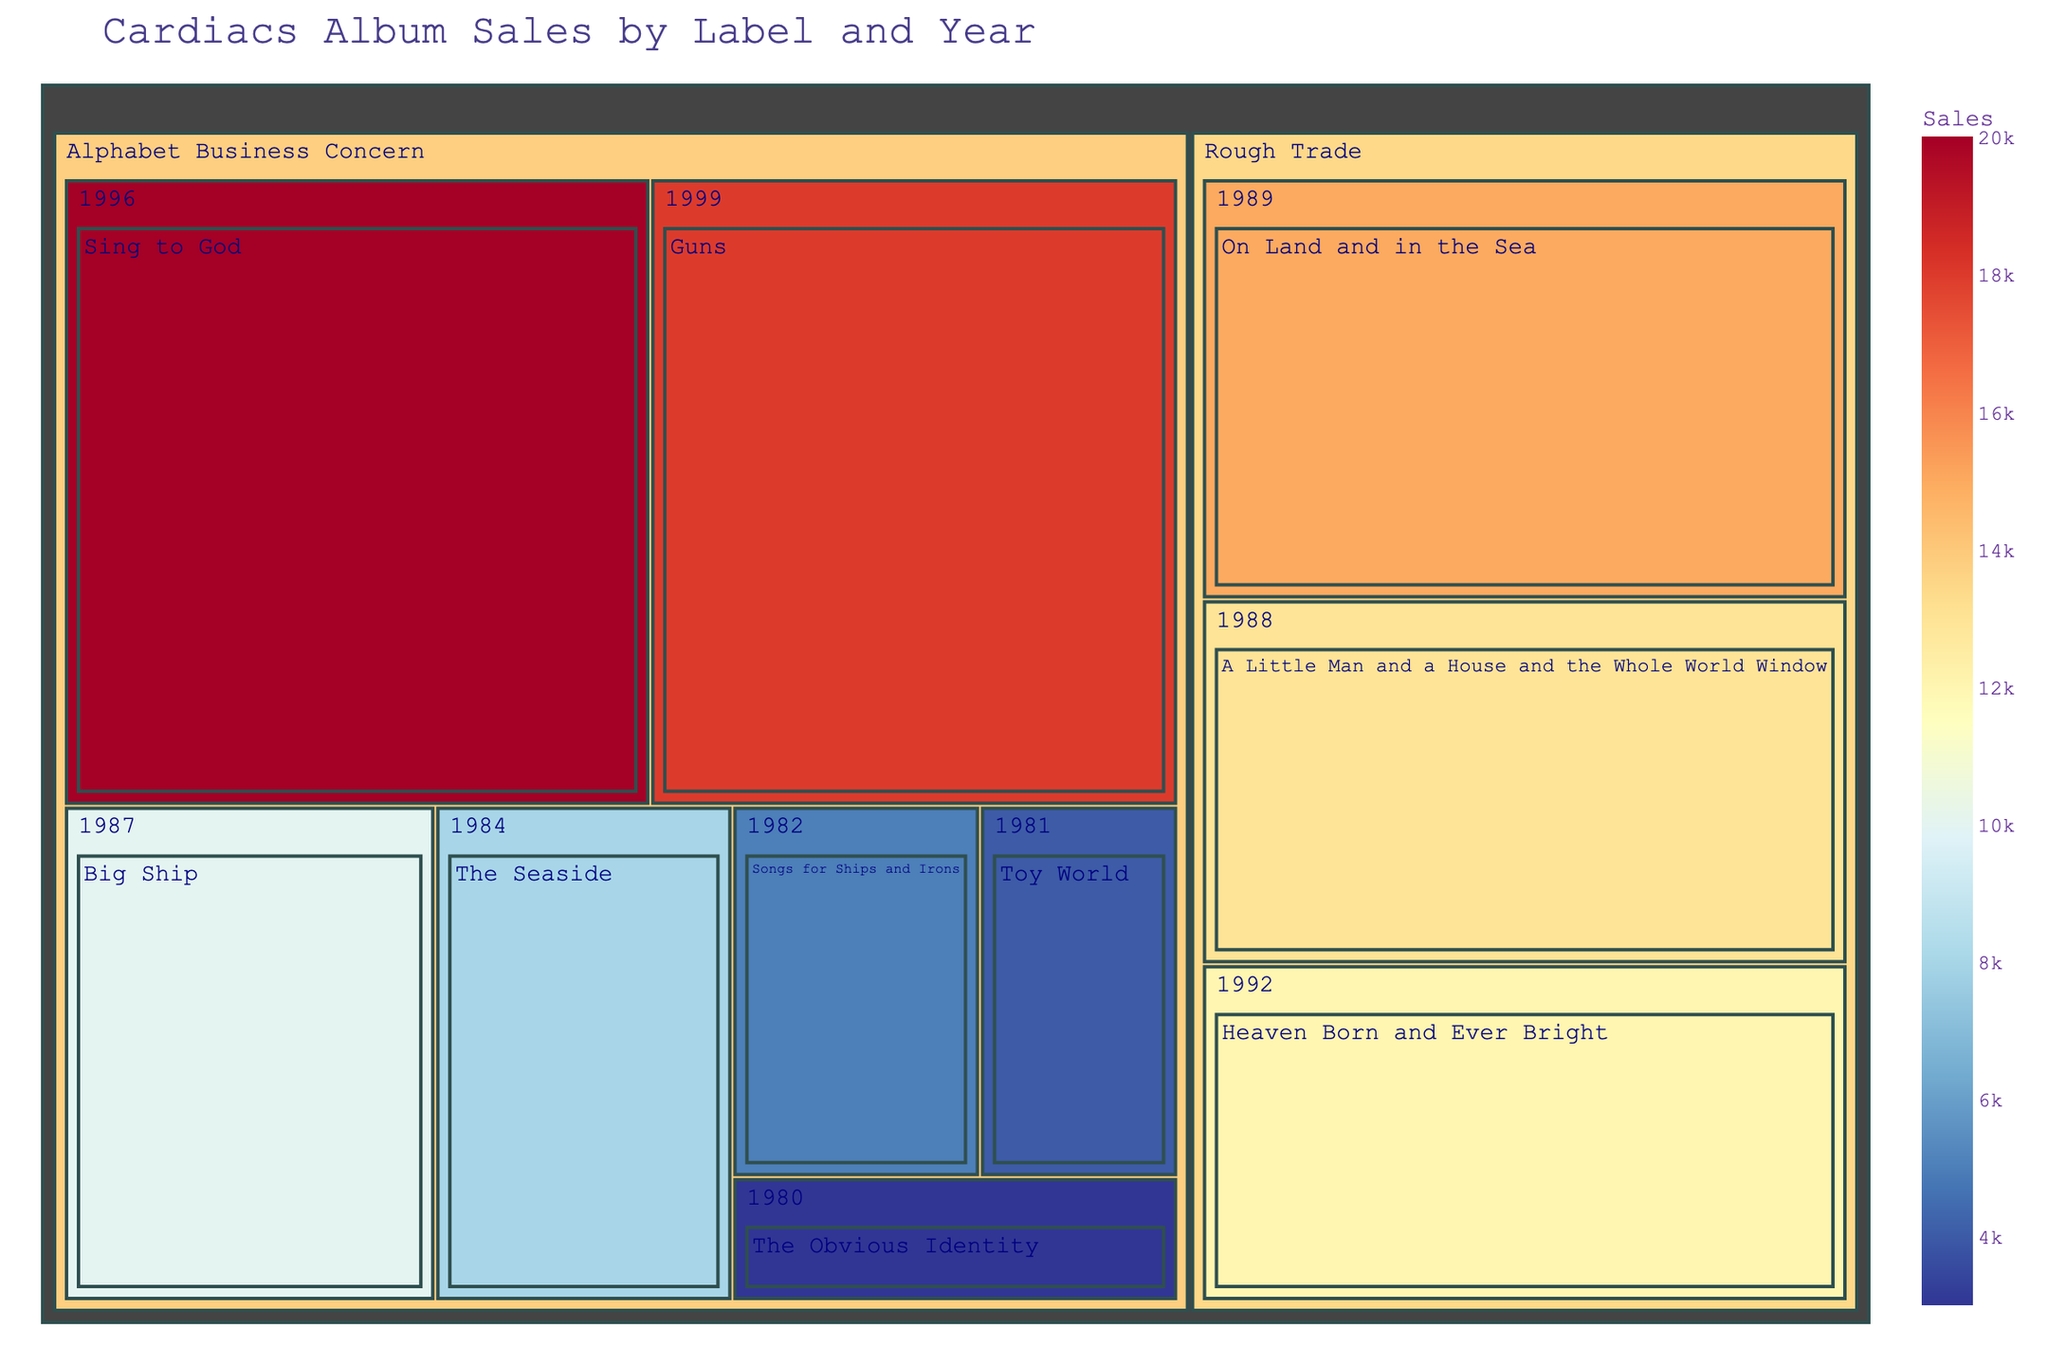what's the title of the figure? The title is prominently displayed at the top of the figure and reads "Cardiacs Album Sales by Label and Year".
Answer: Cardiacs Album Sales by Label and Year which album has the highest sales and how many sales does it have? By looking at the size of the blocks, the largest block denotes the album "Sing to God" with 20,000 sales.
Answer: Sing to God, 20,000 how many albums were released under the Rough Trade label? Rough Trade label has three distinct blocks denoting albums, "On Land and in the Sea", "Heaven Born and Ever Bright", and "A Little Man and a House and the Whole World Window".
Answer: 3 what is the combined sales of albums released by Alphabet Business Concern in 1996 and 1999? Albums "Sing to God" (1996) and "Guns" (1999) are both under Alphabet Business Concern. Summing the sales of these two albums, we get 20,000 + 18,000 = 38,000.
Answer: 38,000 which year had the most diverse range of album labels and how many labels were present in that year? By observing the year groups, 1989 had albums from only Rough Trade, while other years do not have more than one label either.
Answer: None, each year had only one label what's the total sales of the albums released by the Rough Trade label? Sum the sales of all albums under Rough Trade: "On Land and in the Sea" (15,000), "Heaven Born and Ever Bright" (12,000), and "A Little Man and a House and the Whole World Window" (13,000). Total = 15,000 + 12,000 + 13,000 = 40,000.
Answer: 40,000 compare the album sales in 1988 and 1989, which year had higher sales and by how much? "A Little Man and a House and the Whole World Window" (1988) had 13,000 sales and "On Land and in the Sea" (1989) had 15,000 sales. Difference = 15,000 - 13,000 = 2,000 sales.
Answer: 1989, by 2,000 sales what album has the smallest sales, and which label is it under? The smallest block represents "The Obvious Identity" with 3,000 sales, released under Alphabet Business Concern.
Answer: The Obvious Identity, Alphabet Business Concern can you identify a pattern related to sales trends over the years for any particular label? Albums under Alphabet Business Concern generally show an increasing trend in sales over the years, peaking with "Sing to God" in 1996 with 20,000 sales.
Answer: Increasing trend for Alphabet Business Concern which record label contributed most to the total album sales and how? By aggregating sales from all albums per label, Alphabet Business Concern totals: 20,000 + 18,000 + 8,000 + 10,000 + 5,000 + 3,000 + 4,000 = 68,000. Rough Trade totals: 15,000 + 12,000 + 13,000 = 40,000. So, Alphabet Business Concern's total is higher.
Answer: Alphabet Business Concern, 68,000 